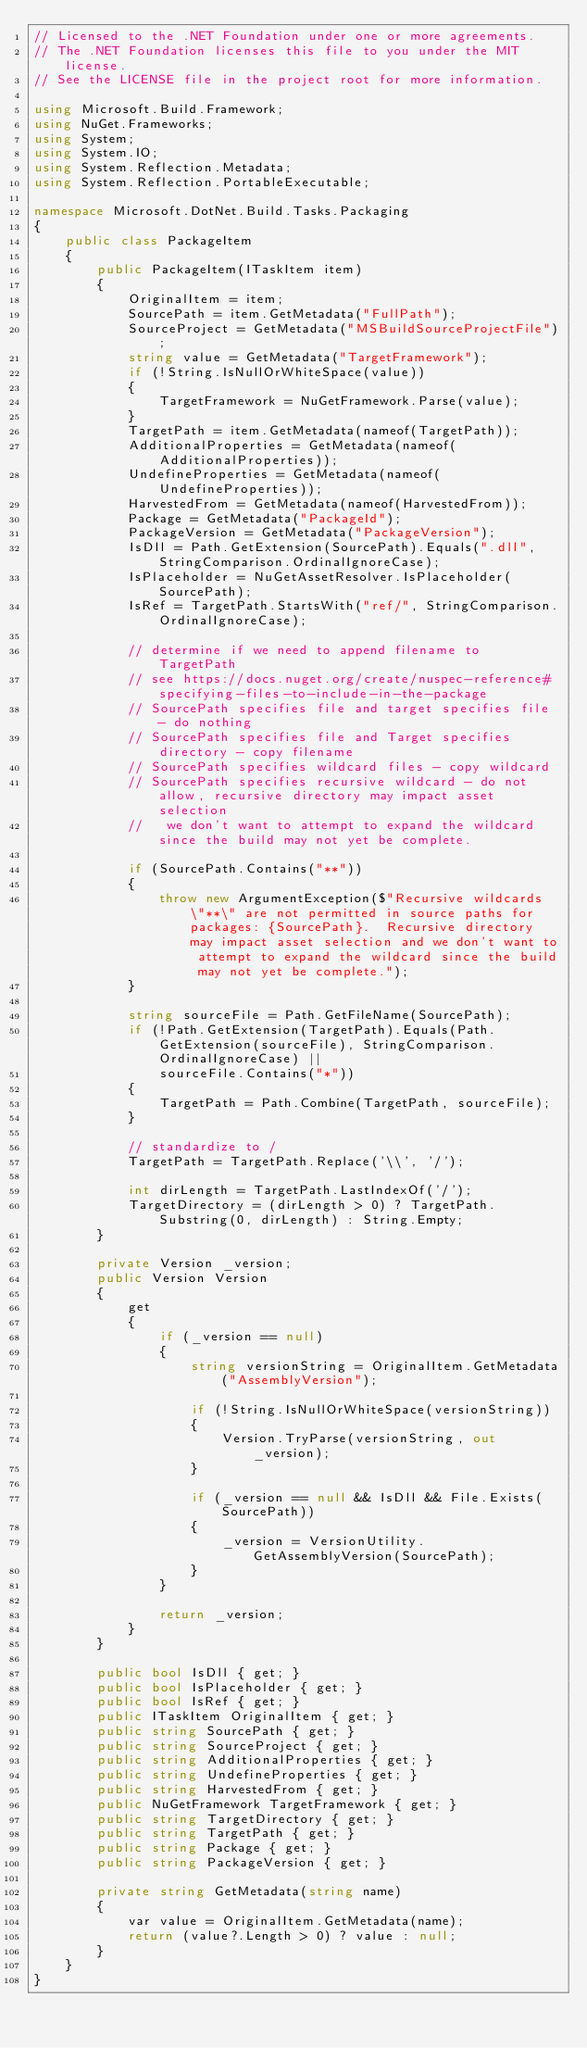Convert code to text. <code><loc_0><loc_0><loc_500><loc_500><_C#_>// Licensed to the .NET Foundation under one or more agreements.
// The .NET Foundation licenses this file to you under the MIT license.
// See the LICENSE file in the project root for more information.

using Microsoft.Build.Framework;
using NuGet.Frameworks;
using System;
using System.IO;
using System.Reflection.Metadata;
using System.Reflection.PortableExecutable;

namespace Microsoft.DotNet.Build.Tasks.Packaging
{
    public class PackageItem
    {
        public PackageItem(ITaskItem item)
        {
            OriginalItem = item;
            SourcePath = item.GetMetadata("FullPath");
            SourceProject = GetMetadata("MSBuildSourceProjectFile");
            string value = GetMetadata("TargetFramework");
            if (!String.IsNullOrWhiteSpace(value))
            {
                TargetFramework = NuGetFramework.Parse(value);
            }
            TargetPath = item.GetMetadata(nameof(TargetPath));
            AdditionalProperties = GetMetadata(nameof(AdditionalProperties));
            UndefineProperties = GetMetadata(nameof(UndefineProperties));
            HarvestedFrom = GetMetadata(nameof(HarvestedFrom));
            Package = GetMetadata("PackageId");
            PackageVersion = GetMetadata("PackageVersion");
            IsDll = Path.GetExtension(SourcePath).Equals(".dll", StringComparison.OrdinalIgnoreCase);
            IsPlaceholder = NuGetAssetResolver.IsPlaceholder(SourcePath);
            IsRef = TargetPath.StartsWith("ref/", StringComparison.OrdinalIgnoreCase);

            // determine if we need to append filename to TargetPath
            // see https://docs.nuget.org/create/nuspec-reference#specifying-files-to-include-in-the-package
            // SourcePath specifies file and target specifies file - do nothing
            // SourcePath specifies file and Target specifies directory - copy filename
            // SourcePath specifies wildcard files - copy wildcard
            // SourcePath specifies recursive wildcard - do not allow, recursive directory may impact asset selection
            //   we don't want to attempt to expand the wildcard since the build may not yet be complete.

            if (SourcePath.Contains("**"))
            {
                throw new ArgumentException($"Recursive wildcards \"**\" are not permitted in source paths for packages: {SourcePath}.  Recursive directory may impact asset selection and we don't want to attempt to expand the wildcard since the build may not yet be complete.");
            }

            string sourceFile = Path.GetFileName(SourcePath);
            if (!Path.GetExtension(TargetPath).Equals(Path.GetExtension(sourceFile), StringComparison.OrdinalIgnoreCase) ||
                sourceFile.Contains("*"))
            {
                TargetPath = Path.Combine(TargetPath, sourceFile);
            }

            // standardize to /
            TargetPath = TargetPath.Replace('\\', '/');

            int dirLength = TargetPath.LastIndexOf('/');
            TargetDirectory = (dirLength > 0) ? TargetPath.Substring(0, dirLength) : String.Empty;
        }

        private Version _version;
        public Version Version
        {
            get
            {
                if (_version == null)
                {
                    string versionString = OriginalItem.GetMetadata("AssemblyVersion");

                    if (!String.IsNullOrWhiteSpace(versionString))
                    {
                        Version.TryParse(versionString, out _version);
                    }

                    if (_version == null && IsDll && File.Exists(SourcePath))
                    {
                        _version = VersionUtility.GetAssemblyVersion(SourcePath);
                    }
                }

                return _version;
            }
        }

        public bool IsDll { get; }
        public bool IsPlaceholder { get; }
        public bool IsRef { get; }
        public ITaskItem OriginalItem { get; }
        public string SourcePath { get; }
        public string SourceProject { get; }
        public string AdditionalProperties { get; }
        public string UndefineProperties { get; }
        public string HarvestedFrom { get; }
        public NuGetFramework TargetFramework { get; }
        public string TargetDirectory { get; }
        public string TargetPath { get; }
        public string Package { get; }
        public string PackageVersion { get; }

        private string GetMetadata(string name)
        {
            var value = OriginalItem.GetMetadata(name);
            return (value?.Length > 0) ? value : null;
        }
    }
}
</code> 